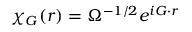Convert formula to latex. <formula><loc_0><loc_0><loc_500><loc_500>\chi _ { G } ( r ) = \Omega ^ { - 1 / 2 } e ^ { i G \cdot r }</formula> 